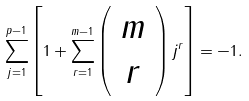Convert formula to latex. <formula><loc_0><loc_0><loc_500><loc_500>\sum _ { j = 1 } ^ { p - 1 } \left [ 1 + \sum _ { r = 1 } ^ { m - 1 } \left ( \begin{array} { c } m \\ r \end{array} \right ) j ^ { r } \right ] = - 1 .</formula> 